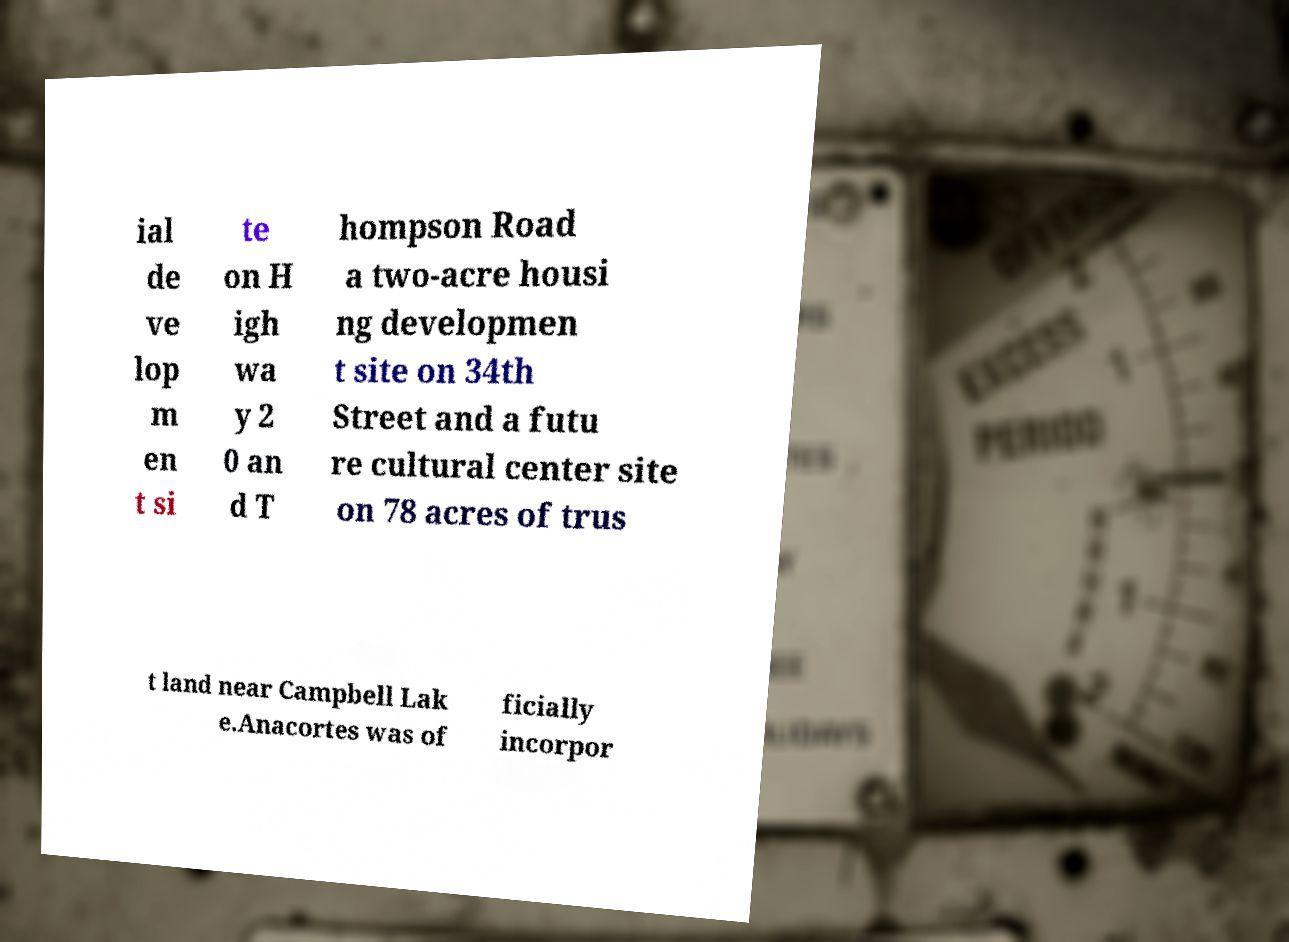Can you accurately transcribe the text from the provided image for me? ial de ve lop m en t si te on H igh wa y 2 0 an d T hompson Road a two-acre housi ng developmen t site on 34th Street and a futu re cultural center site on 78 acres of trus t land near Campbell Lak e.Anacortes was of ficially incorpor 